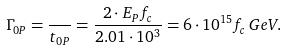<formula> <loc_0><loc_0><loc_500><loc_500>\Gamma _ { 0 P } = \frac { } { t _ { 0 P } } = \frac { 2 \cdot E _ { P } f _ { c } } { 2 . 0 1 \cdot 1 0 ^ { 3 } } = 6 \cdot 1 0 ^ { 1 5 } f _ { c } \, G e V .</formula> 